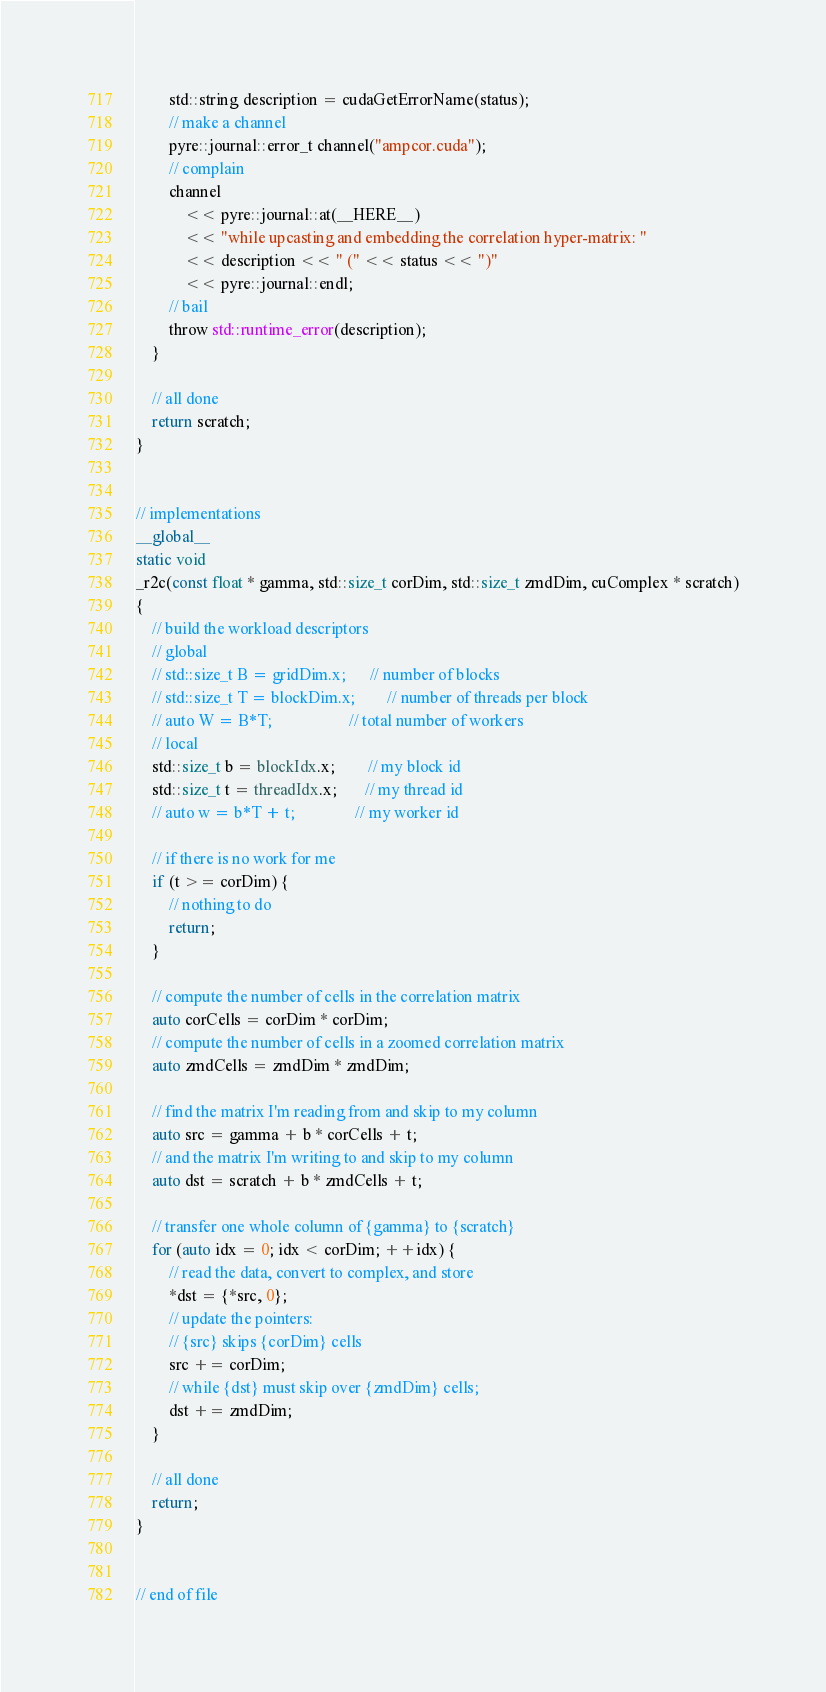Convert code to text. <code><loc_0><loc_0><loc_500><loc_500><_Cuda_>        std::string description = cudaGetErrorName(status);
        // make a channel
        pyre::journal::error_t channel("ampcor.cuda");
        // complain
        channel
            << pyre::journal::at(__HERE__)
            << "while upcasting and embedding the correlation hyper-matrix: "
            << description << " (" << status << ")"
            << pyre::journal::endl;
        // bail
        throw std::runtime_error(description);
    }

    // all done
    return scratch;
}


// implementations
__global__
static void
_r2c(const float * gamma, std::size_t corDim, std::size_t zmdDim, cuComplex * scratch)
{
    // build the workload descriptors
    // global
    // std::size_t B = gridDim.x;      // number of blocks
    // std::size_t T = blockDim.x;        // number of threads per block
    // auto W = B*T;                   // total number of workers
    // local
    std::size_t b = blockIdx.x;        // my block id
    std::size_t t = threadIdx.x;       // my thread id
    // auto w = b*T + t;               // my worker id

    // if there is no work for me
    if (t >= corDim) {
        // nothing to do
        return;
    }

    // compute the number of cells in the correlation matrix
    auto corCells = corDim * corDim;
    // compute the number of cells in a zoomed correlation matrix
    auto zmdCells = zmdDim * zmdDim;

    // find the matrix I'm reading from and skip to my column
    auto src = gamma + b * corCells + t;
    // and the matrix I'm writing to and skip to my column
    auto dst = scratch + b * zmdCells + t;

    // transfer one whole column of {gamma} to {scratch}
    for (auto idx = 0; idx < corDim; ++idx) {
        // read the data, convert to complex, and store
        *dst = {*src, 0};
        // update the pointers:
        // {src} skips {corDim} cells
        src += corDim;
        // while {dst} must skip over {zmdDim} cells;
        dst += zmdDim;
    }

    // all done
    return;
}


// end of file
</code> 